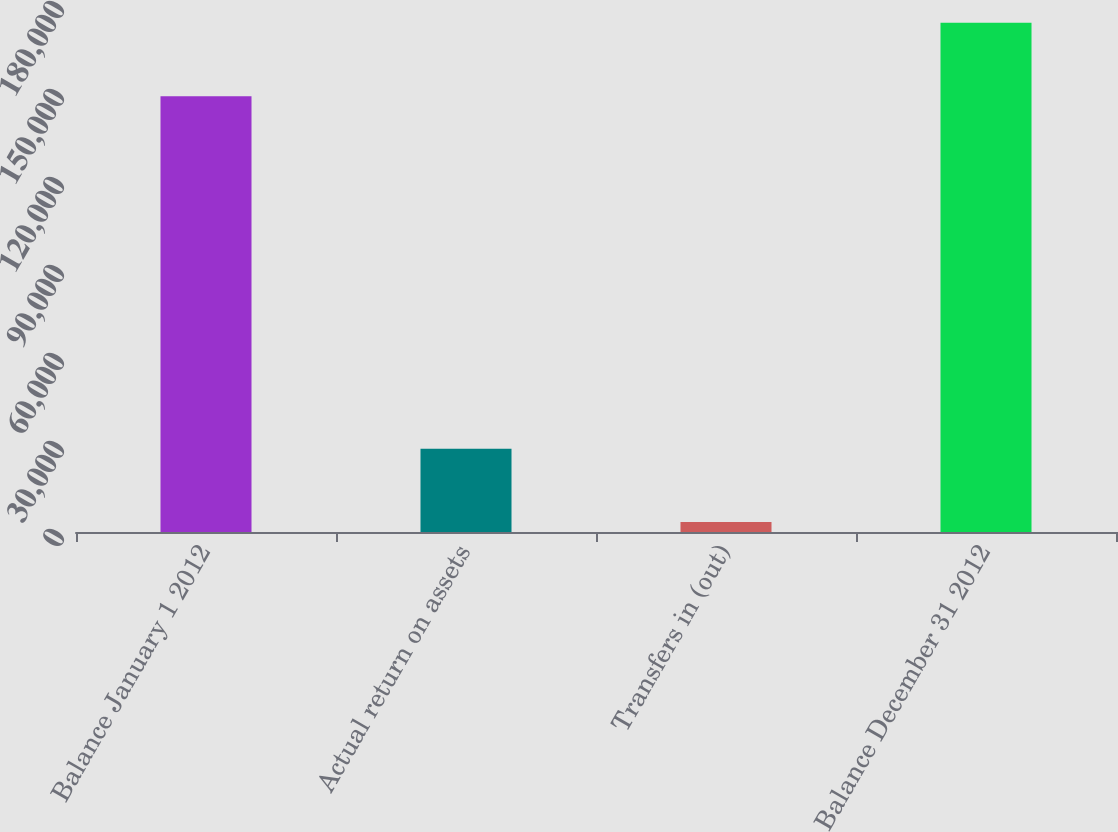<chart> <loc_0><loc_0><loc_500><loc_500><bar_chart><fcel>Balance January 1 2012<fcel>Actual return on assets<fcel>Transfers in (out)<fcel>Balance December 31 2012<nl><fcel>148574<fcel>28420<fcel>3369<fcel>173625<nl></chart> 